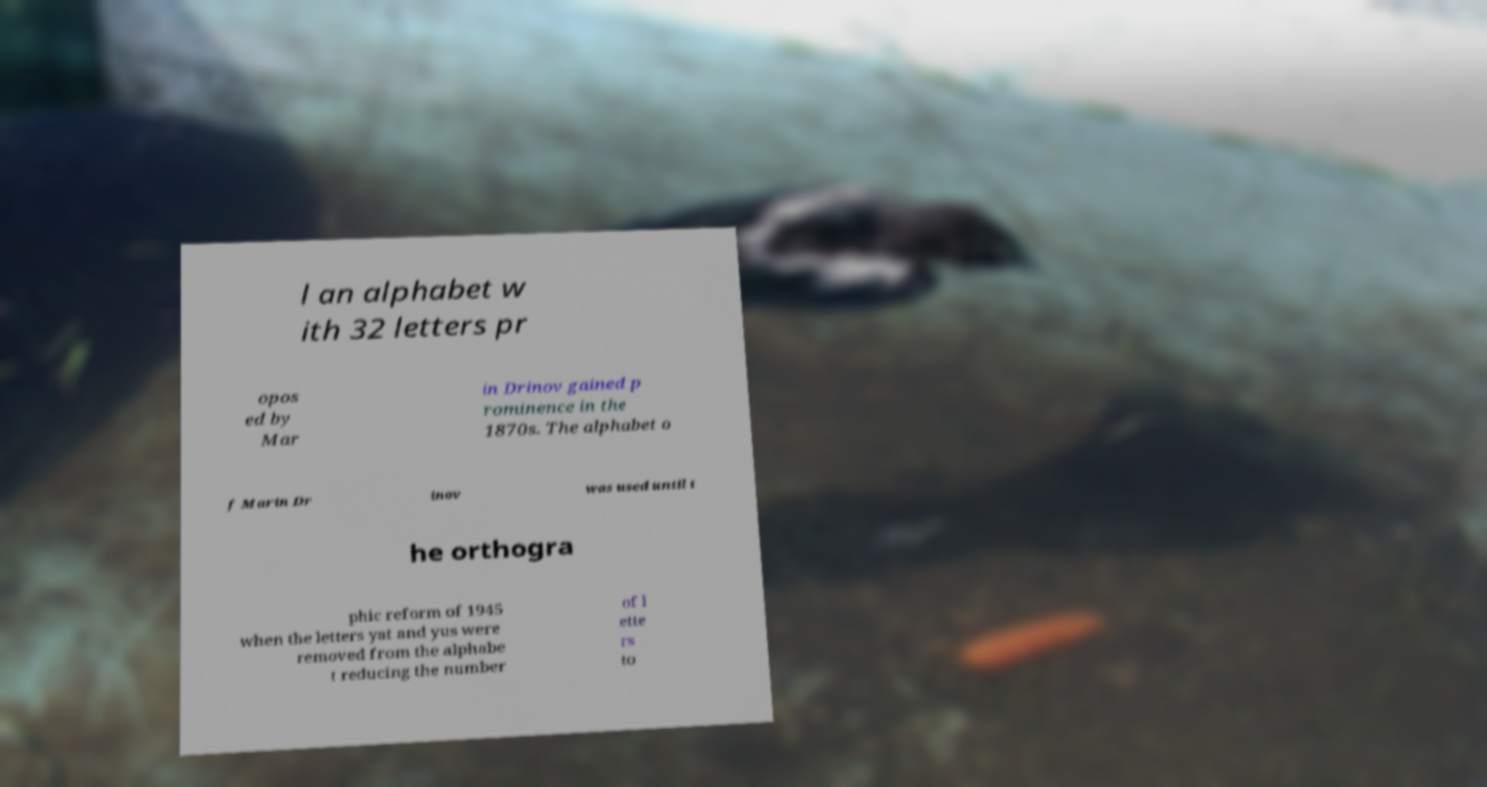There's text embedded in this image that I need extracted. Can you transcribe it verbatim? l an alphabet w ith 32 letters pr opos ed by Mar in Drinov gained p rominence in the 1870s. The alphabet o f Marin Dr inov was used until t he orthogra phic reform of 1945 when the letters yat and yus were removed from the alphabe t reducing the number of l ette rs to 